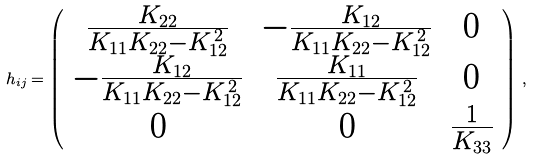Convert formula to latex. <formula><loc_0><loc_0><loc_500><loc_500>h _ { i j } = \left ( \begin{array} { c c c } \frac { K _ { 2 2 } } { K _ { 1 1 } K _ { 2 2 } - K _ { 1 2 } ^ { \, 2 } } & - \frac { K _ { 1 2 } } { K _ { 1 1 } K _ { 2 2 } - K _ { 1 2 } ^ { \, 2 } } & 0 \\ - \frac { K _ { 1 2 } } { K _ { 1 1 } K _ { 2 2 } - K _ { 1 2 } ^ { \, 2 } } & \frac { K _ { 1 1 } } { K _ { 1 1 } K _ { 2 2 } - K _ { 1 2 } ^ { \, 2 } } & 0 \\ 0 & 0 & \frac { 1 } { K _ { 3 3 } } \end{array} \right ) \, ,</formula> 